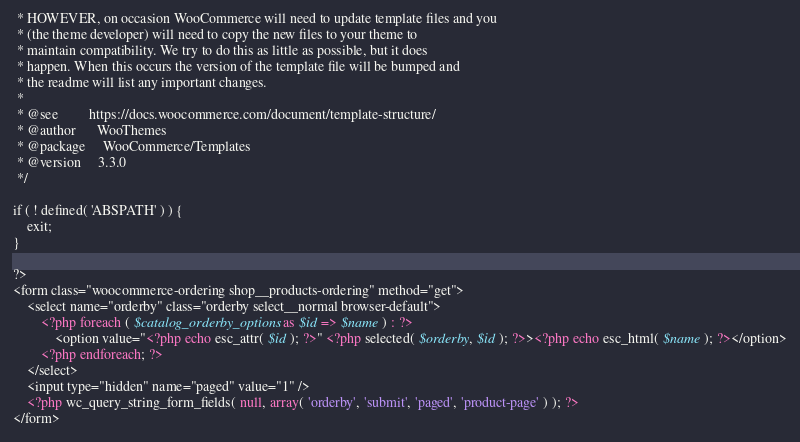Convert code to text. <code><loc_0><loc_0><loc_500><loc_500><_PHP_> * HOWEVER, on occasion WooCommerce will need to update template files and you
 * (the theme developer) will need to copy the new files to your theme to
 * maintain compatibility. We try to do this as little as possible, but it does
 * happen. When this occurs the version of the template file will be bumped and
 * the readme will list any important changes.
 *
 * @see 	    https://docs.woocommerce.com/document/template-structure/
 * @author 		WooThemes
 * @package 	WooCommerce/Templates
 * @version     3.3.0
 */

if ( ! defined( 'ABSPATH' ) ) {
	exit;
}

?>
<form class="woocommerce-ordering shop__products-ordering" method="get">
	<select name="orderby" class="orderby select__normal browser-default">
		<?php foreach ( $catalog_orderby_options as $id => $name ) : ?>
			<option value="<?php echo esc_attr( $id ); ?>" <?php selected( $orderby, $id ); ?>><?php echo esc_html( $name ); ?></option>
		<?php endforeach; ?>
	</select>
	<input type="hidden" name="paged" value="1" />
	<?php wc_query_string_form_fields( null, array( 'orderby', 'submit', 'paged', 'product-page' ) ); ?>
</form>
</code> 